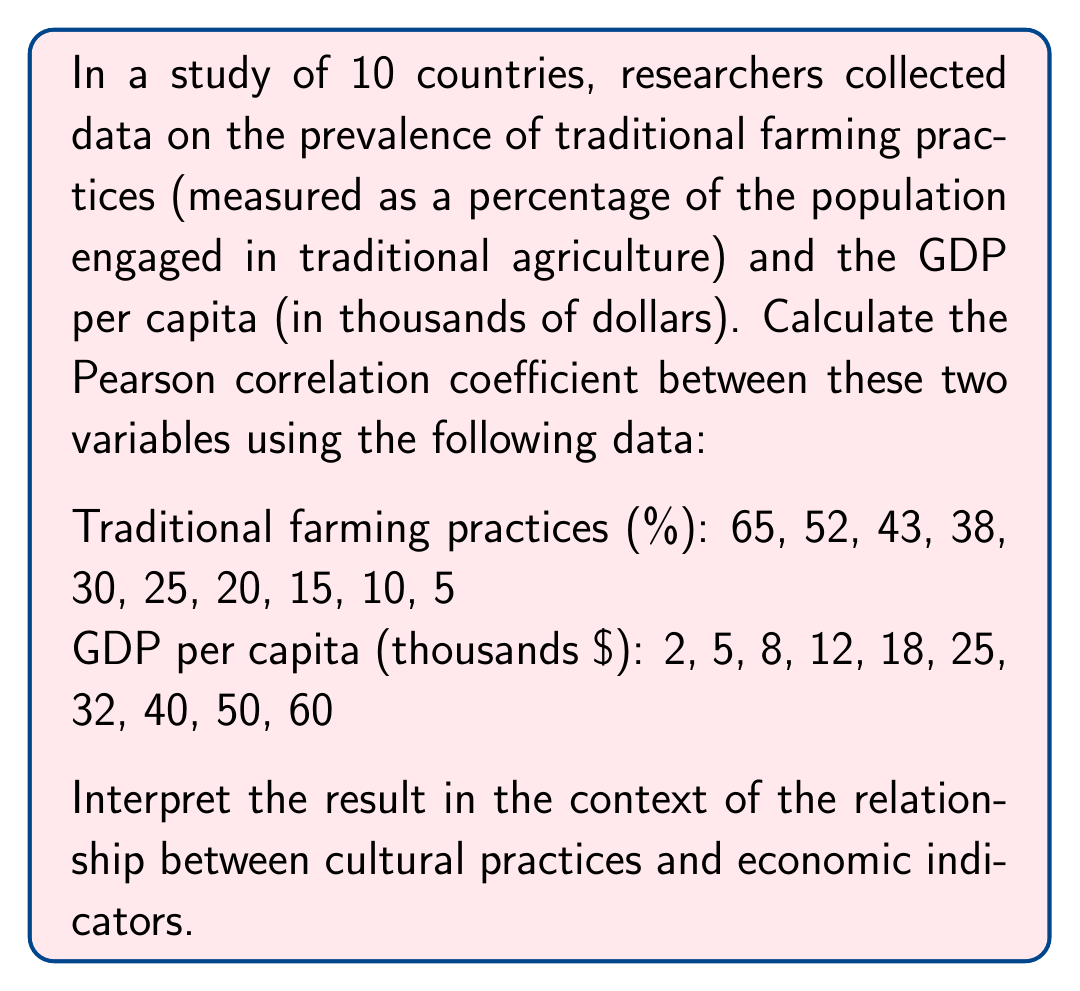What is the answer to this math problem? To calculate the Pearson correlation coefficient, we'll follow these steps:

1. Calculate the means of X (traditional farming practices) and Y (GDP per capita):

$$ \bar{X} = \frac{65 + 52 + 43 + 38 + 30 + 25 + 20 + 15 + 10 + 5}{10} = 30.3 $$
$$ \bar{Y} = \frac{2 + 5 + 8 + 12 + 18 + 25 + 32 + 40 + 50 + 60}{10} = 25.2 $$

2. Calculate the deviations from the mean for each variable:

$X - \bar{X}$: 34.7, 21.7, 12.7, 7.7, -0.3, -5.3, -10.3, -15.3, -20.3, -25.3
$Y - \bar{Y}$: -23.2, -20.2, -17.2, -13.2, -7.2, -0.2, 6.8, 14.8, 24.8, 34.8

3. Calculate the products of the deviations:

$(X - \bar{X})(Y - \bar{Y})$: -804.04, -438.34, -218.44, -101.64, 2.16, 1.06, -70.04, -226.44, -503.44, -880.44

4. Calculate the sums needed for the correlation coefficient:

$$ \sum(X - \bar{X})(Y - \bar{Y}) = -3239.6 $$
$$ \sum(X - \bar{X})^2 = 4374.1 $$
$$ \sum(Y - \bar{Y})^2 = 4621.6 $$

5. Apply the Pearson correlation coefficient formula:

$$ r = \frac{\sum(X - \bar{X})(Y - \bar{Y})}{\sqrt{\sum(X - \bar{X})^2 \sum(Y - \bar{Y})^2}} $$

$$ r = \frac{-3239.6}{\sqrt{4374.1 \times 4621.6}} = \frac{-3239.6}{4495.35} \approx -0.9706 $$

The correlation coefficient is approximately -0.9706, indicating a very strong negative correlation between traditional farming practices and GDP per capita.

Interpretation: This strong negative correlation suggests that as the prevalence of traditional farming practices decreases, the GDP per capita tends to increase, and vice versa. This relationship highlights a potential link between cultural practices (represented by traditional farming) and economic indicators (represented by GDP per capita). It's important to note that correlation does not imply causation, and other factors may influence this relationship.
Answer: The Pearson correlation coefficient is approximately -0.9706, indicating a very strong negative correlation between traditional farming practices and GDP per capita. 